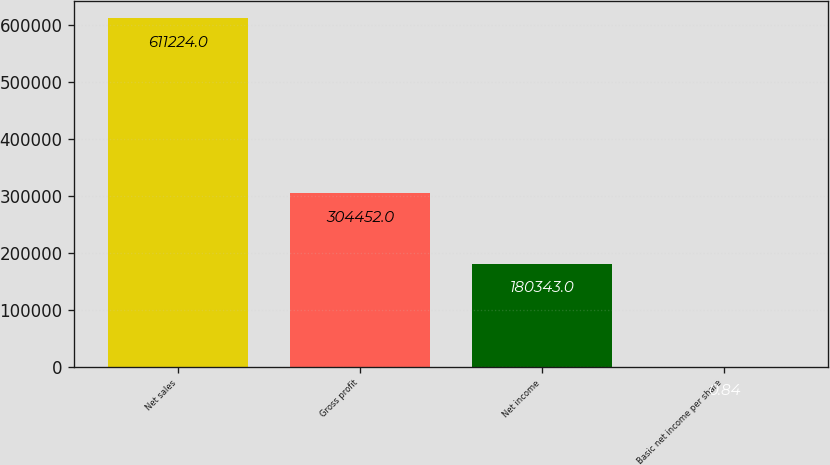Convert chart. <chart><loc_0><loc_0><loc_500><loc_500><bar_chart><fcel>Net sales<fcel>Gross profit<fcel>Net income<fcel>Basic net income per share<nl><fcel>611224<fcel>304452<fcel>180343<fcel>0.84<nl></chart> 